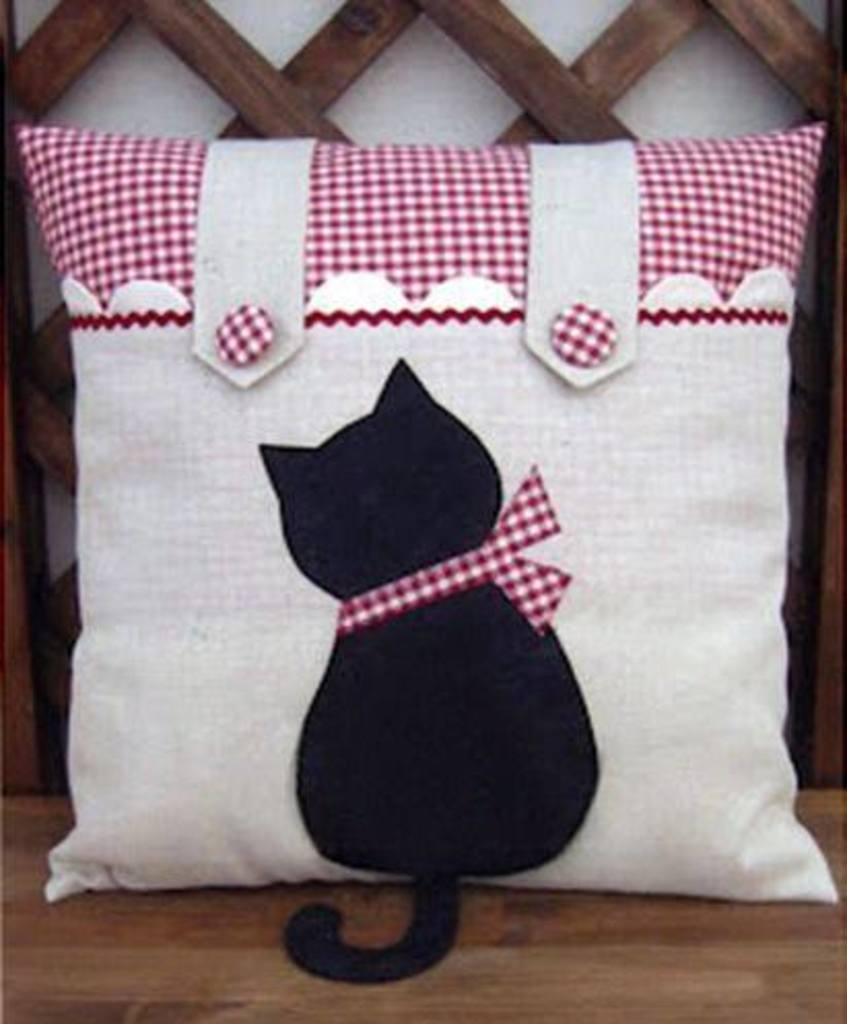What is on the pillow that is visible in the image? There is an image on the pillow in the image. Where is the pillow located? The pillow is on a surface in the image. What can be seen in the background of the image? There is a wall visible in the background of the image. What material is present on the wall? There is wood present on the wall in the image. How does the nerve affect the pillow in the image? There is no mention of a nerve in the image, so it cannot affect the pillow. 